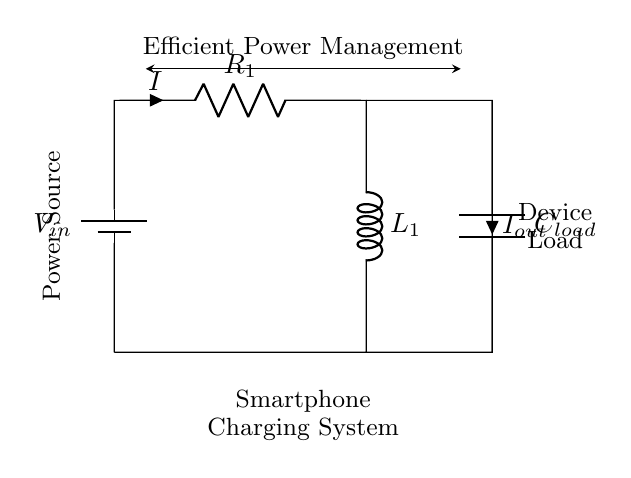What is the primary power source in this circuit? The primary power source is designated as V_in, which indicates the input voltage provided by the battery in the circuit.
Answer: V_in What components are used in this RL circuit? The components in this circuit include a resistor R_1, an inductor L_1, a capacitor C_load, and a battery V_in, which are essential in managing the flow of electric current.
Answer: R_1, L_1, C_load, V_in What does the arrow on the inductor L_1 indicate? The arrow indicates the direction of the current flow through the inductor, which opposes changes in current due to its inductive properties.
Answer: Current direction How does the load C_load connect in the circuit? The load C_load is connected in parallel with the output, allowing it to receive current directly from the output line while also affecting the overall impedance of the circuit.
Answer: In parallel What role does the resistor R_1 play in this circuit? The resistor R_1 limits the amount of current flowing through the circuit, which is crucial for preventing damage to the components and controlling voltage levels across the inductor and load.
Answer: Current limiting How does the inductor L_1 affect current during charging? The inductor L_1 stores energy in its magnetic field and releases it gradually, smoothing out variations in current and improving efficiency in the charging process.
Answer: Energy storage 